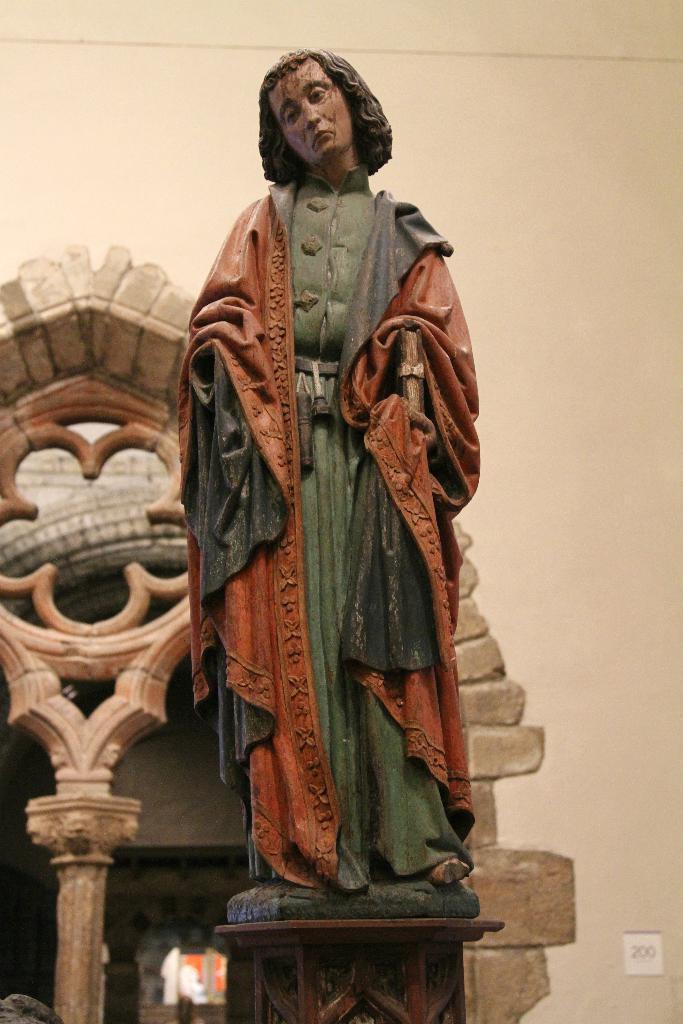Please provide a concise description of this image. In this image we can see a statue is standing. Background of the image one wall is there with one pillar. 